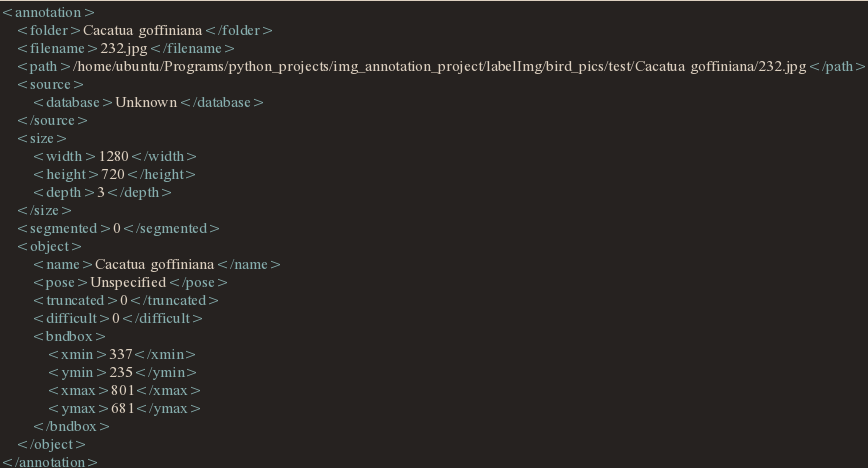<code> <loc_0><loc_0><loc_500><loc_500><_XML_><annotation>
	<folder>Cacatua goffiniana</folder>
	<filename>232.jpg</filename>
	<path>/home/ubuntu/Programs/python_projects/img_annotation_project/labelImg/bird_pics/test/Cacatua goffiniana/232.jpg</path>
	<source>
		<database>Unknown</database>
	</source>
	<size>
		<width>1280</width>
		<height>720</height>
		<depth>3</depth>
	</size>
	<segmented>0</segmented>
	<object>
		<name>Cacatua goffiniana</name>
		<pose>Unspecified</pose>
		<truncated>0</truncated>
		<difficult>0</difficult>
		<bndbox>
			<xmin>337</xmin>
			<ymin>235</ymin>
			<xmax>801</xmax>
			<ymax>681</ymax>
		</bndbox>
	</object>
</annotation>
</code> 